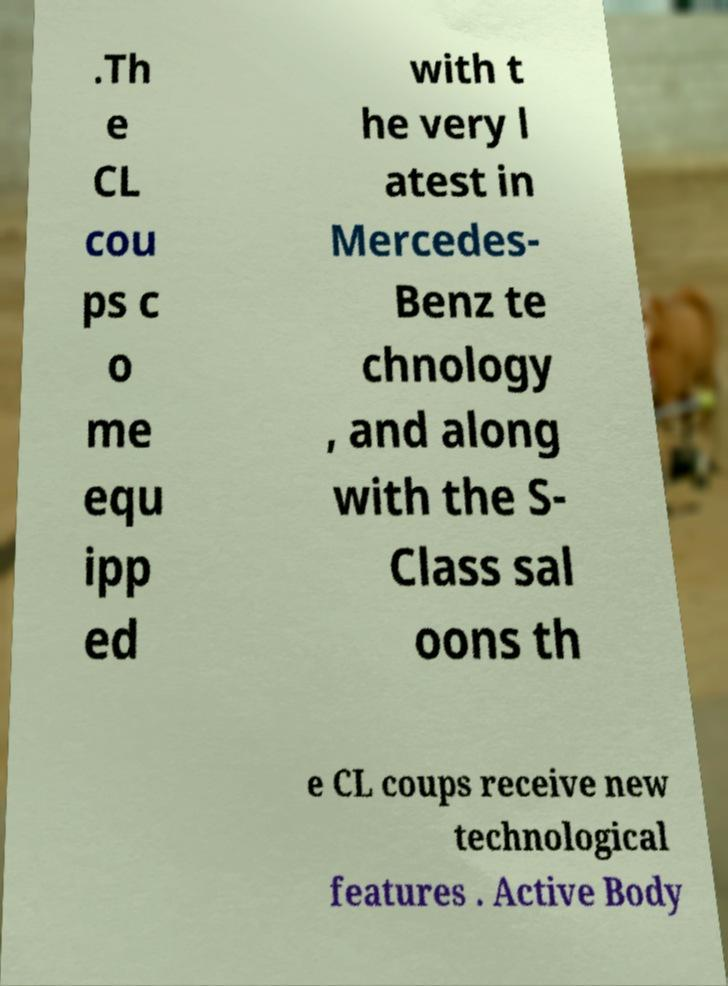Please identify and transcribe the text found in this image. .Th e CL cou ps c o me equ ipp ed with t he very l atest in Mercedes- Benz te chnology , and along with the S- Class sal oons th e CL coups receive new technological features . Active Body 